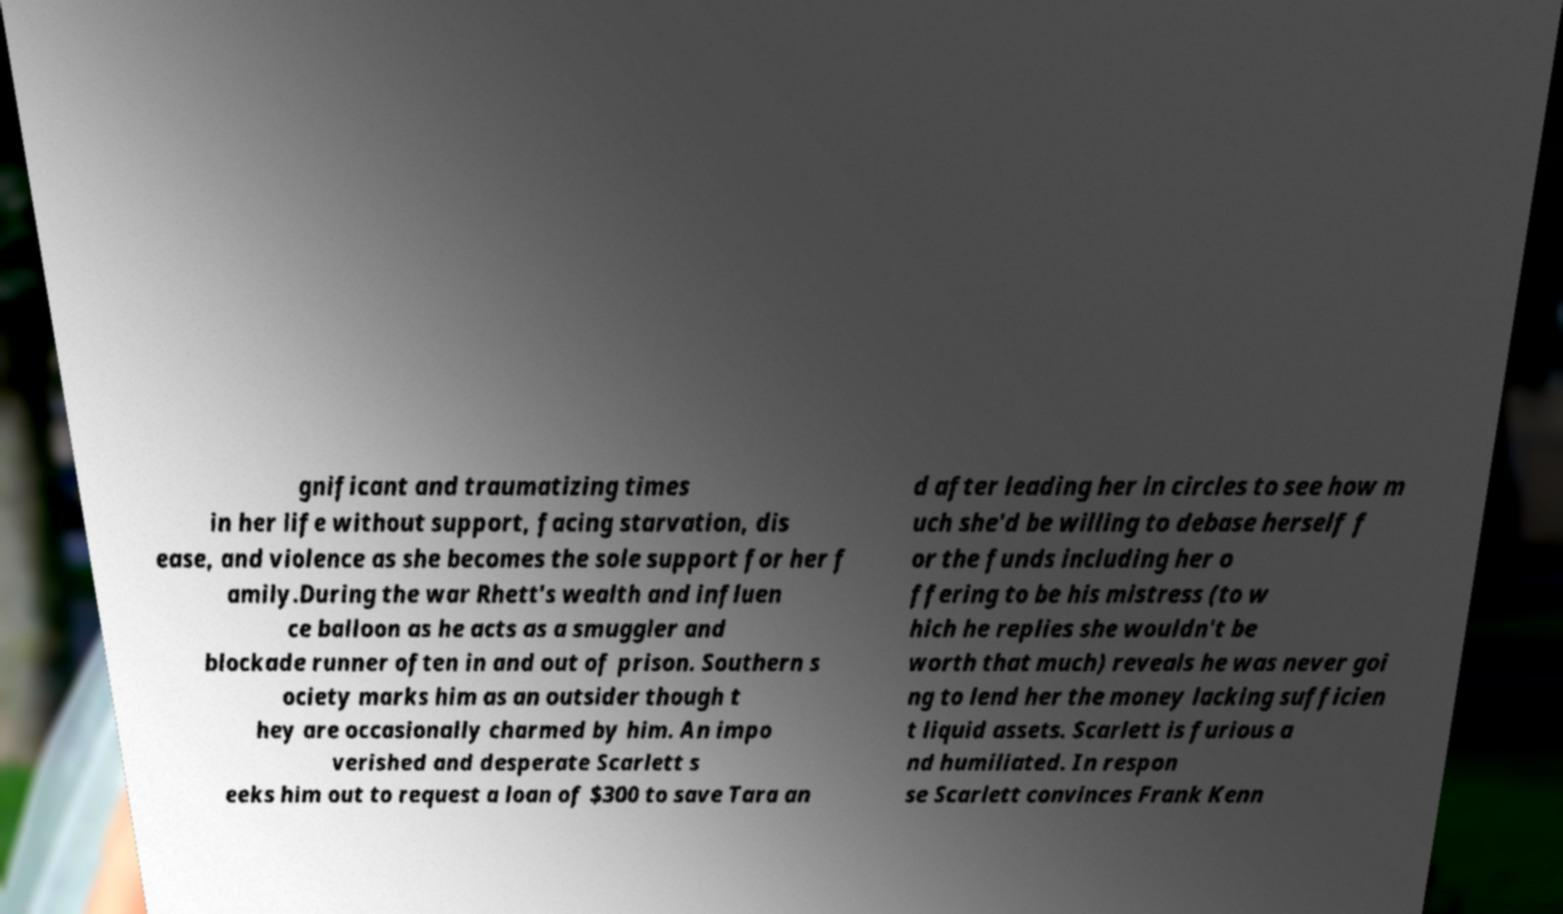Can you accurately transcribe the text from the provided image for me? gnificant and traumatizing times in her life without support, facing starvation, dis ease, and violence as she becomes the sole support for her f amily.During the war Rhett's wealth and influen ce balloon as he acts as a smuggler and blockade runner often in and out of prison. Southern s ociety marks him as an outsider though t hey are occasionally charmed by him. An impo verished and desperate Scarlett s eeks him out to request a loan of $300 to save Tara an d after leading her in circles to see how m uch she'd be willing to debase herself f or the funds including her o ffering to be his mistress (to w hich he replies she wouldn't be worth that much) reveals he was never goi ng to lend her the money lacking sufficien t liquid assets. Scarlett is furious a nd humiliated. In respon se Scarlett convinces Frank Kenn 